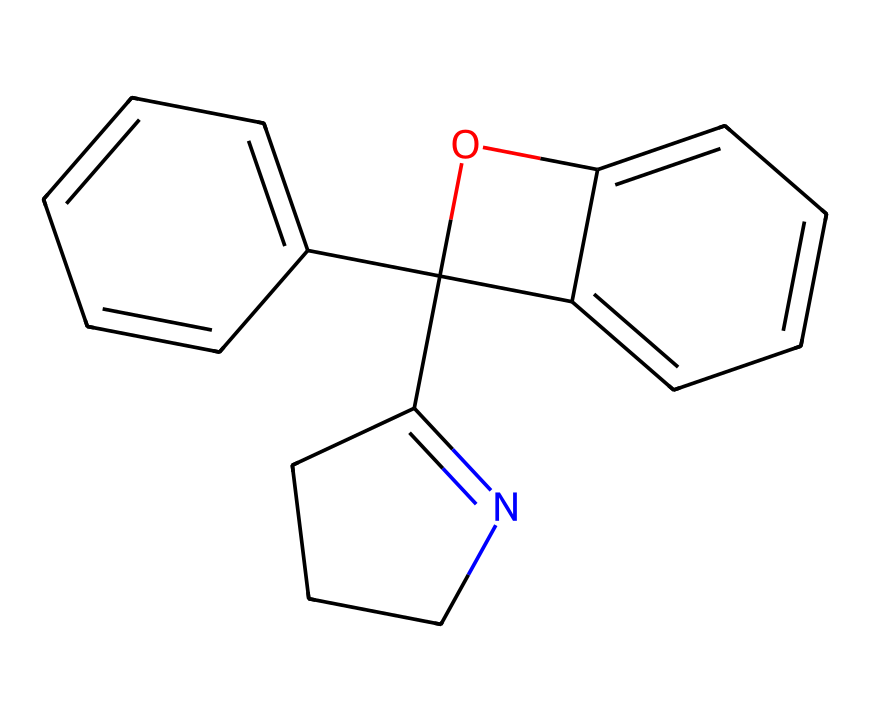What is the primary functional group present in this compound? The chemical structure contains a nitrogen atom that is part of a five-membered ring, indicating it likely has an amine or amide functional group present.
Answer: amine How many carbon atoms are in the compound? By examining the structure, we can count the distinct carbon atoms present, which totals to 15.
Answer: 15 What type of solid structure does this compound likely form? Given that the chemical is photochromic and considering its crystalline nature due to the well-defined aromatic rings, it likely forms a crystalline solid.
Answer: crystalline What is the role of the photochromic nature of this compound in special effects? The photochromic nature allows the compound to change color upon exposure to light, which can create dynamic visual effects in films.
Answer: dynamic visual effects Which molecular structure indicates potential for light interaction? The presence of conjugated systems (like the aromatic rings) allows for electronic transitions, enabling the material to exhibit photochromism.
Answer: conjugated systems 